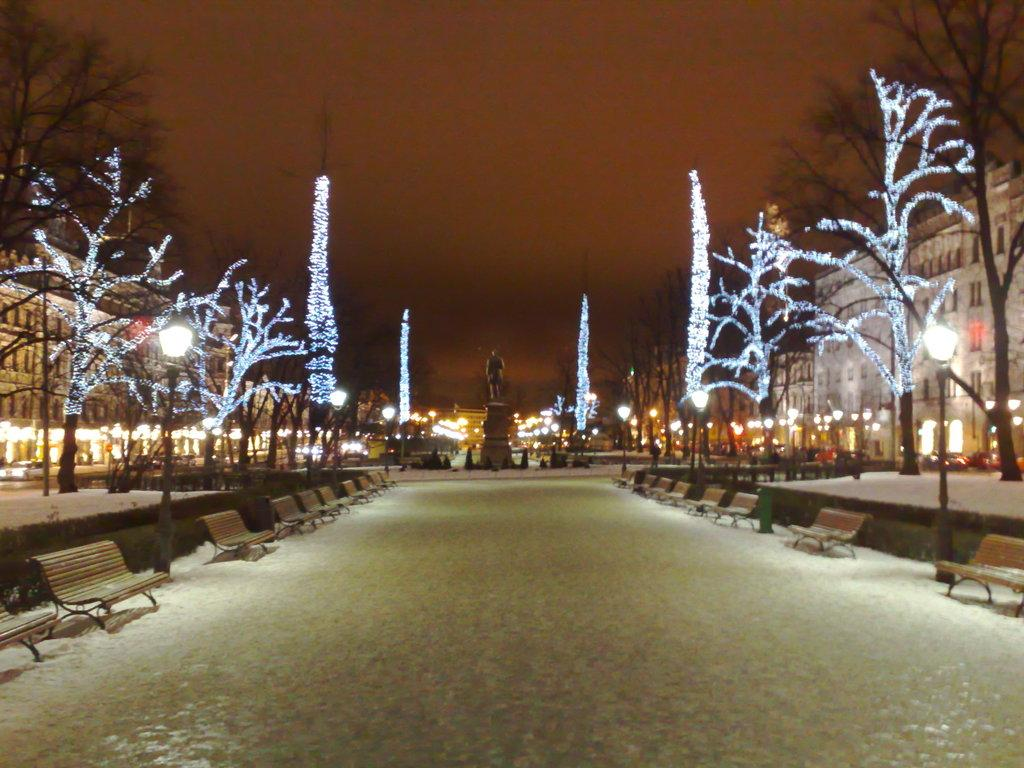What is visible on the ground in the image? The ground is visible in the image, and there are benches on the ground. What else can be seen on the ground in the image? There is a pole in the image. What type of lighting is present in the image? There are lights in the image, and there are trees with lights. What type of structures are visible in the image? There are buildings in the image, and there is a statue in the image. What is visible in the sky in the image? The sky is visible in the image. How many houses are visible in the image? There are no houses visible in the image; the structures present are buildings and a statue. What type of oil is being used to light the trees in the image? There is no oil present in the image; the trees with lights are illuminated by electric lights. 